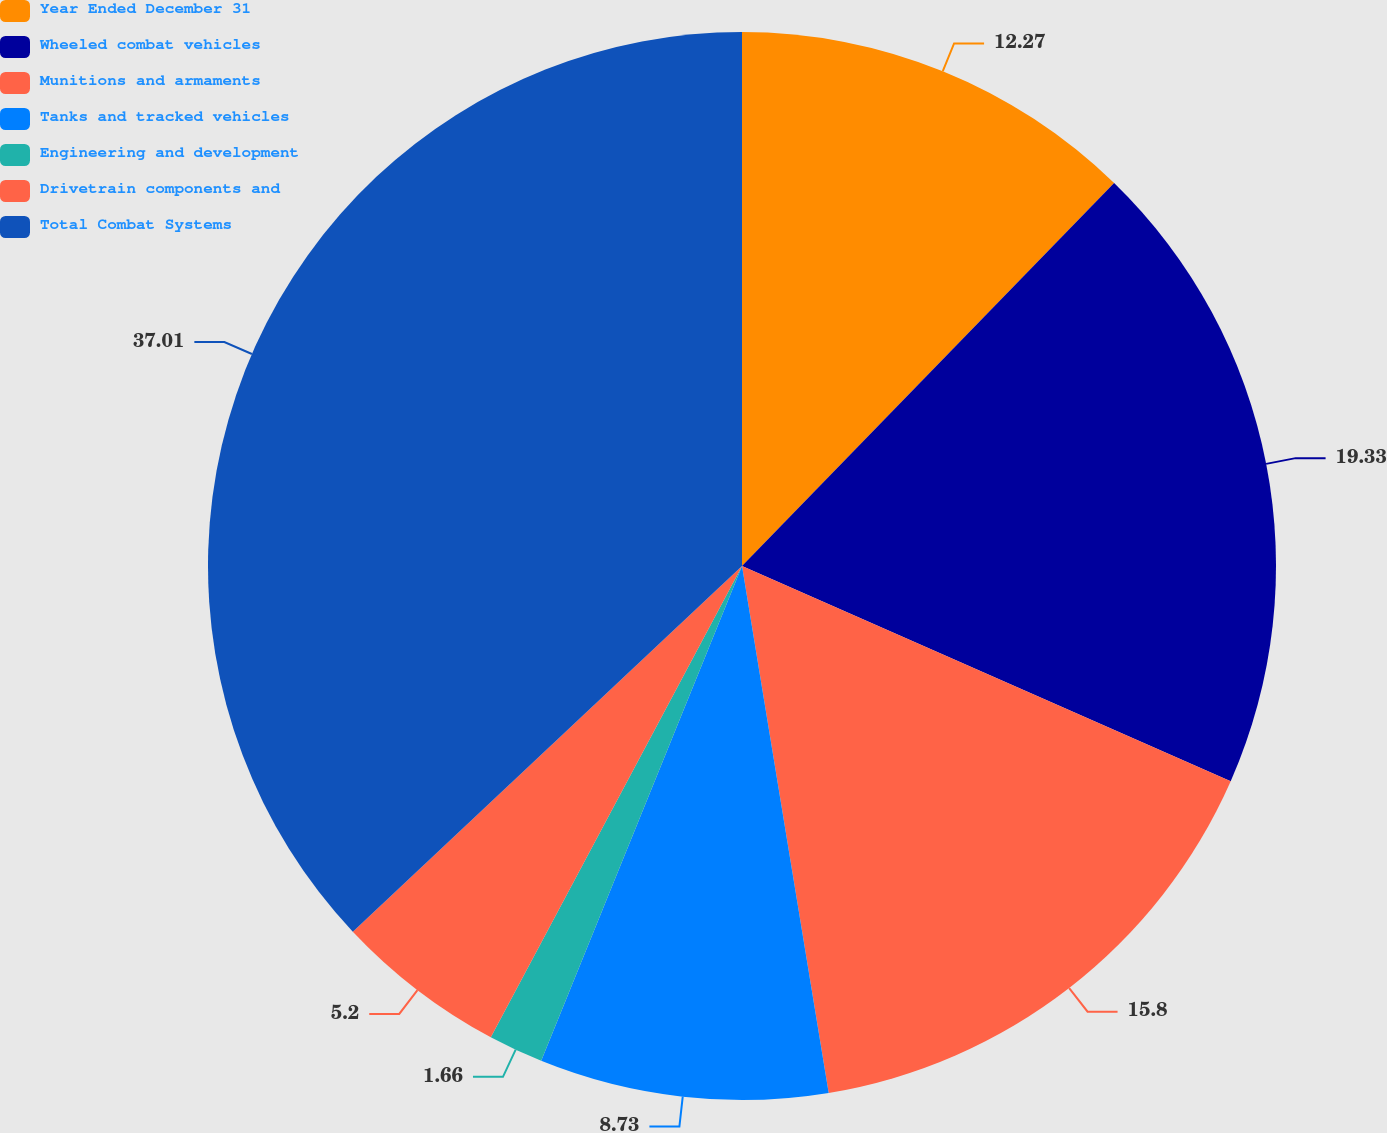Convert chart. <chart><loc_0><loc_0><loc_500><loc_500><pie_chart><fcel>Year Ended December 31<fcel>Wheeled combat vehicles<fcel>Munitions and armaments<fcel>Tanks and tracked vehicles<fcel>Engineering and development<fcel>Drivetrain components and<fcel>Total Combat Systems<nl><fcel>12.27%<fcel>19.33%<fcel>15.8%<fcel>8.73%<fcel>1.66%<fcel>5.2%<fcel>37.0%<nl></chart> 